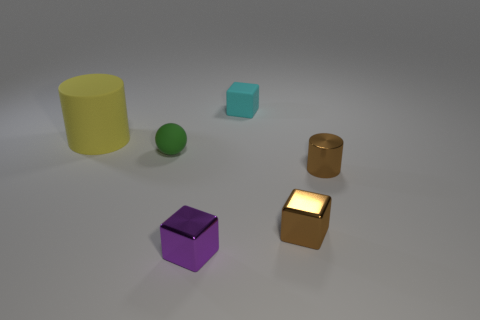Can you describe the colors and shapes of the objects in the image? Certainly! There are six objects in the image with varying colors and shapes. We have a large yellow cylinder, a small green sphere, a small turquoise cube, a medium-sized brown cylinder, a medium-sized purple cube, and a small golden cube with a glowing face. Each object has its own distinct hue and geometric form. 